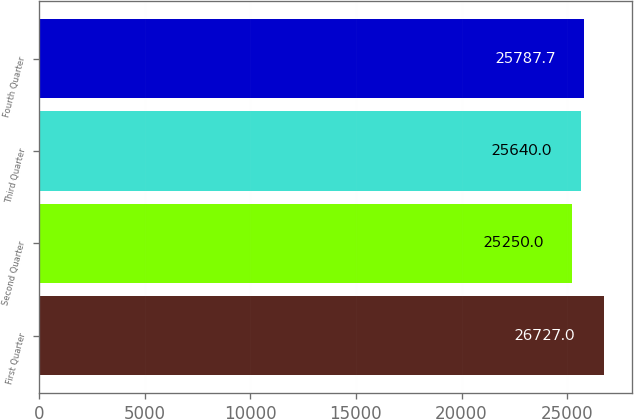Convert chart. <chart><loc_0><loc_0><loc_500><loc_500><bar_chart><fcel>First Quarter<fcel>Second Quarter<fcel>Third Quarter<fcel>Fourth Quarter<nl><fcel>26727<fcel>25250<fcel>25640<fcel>25787.7<nl></chart> 